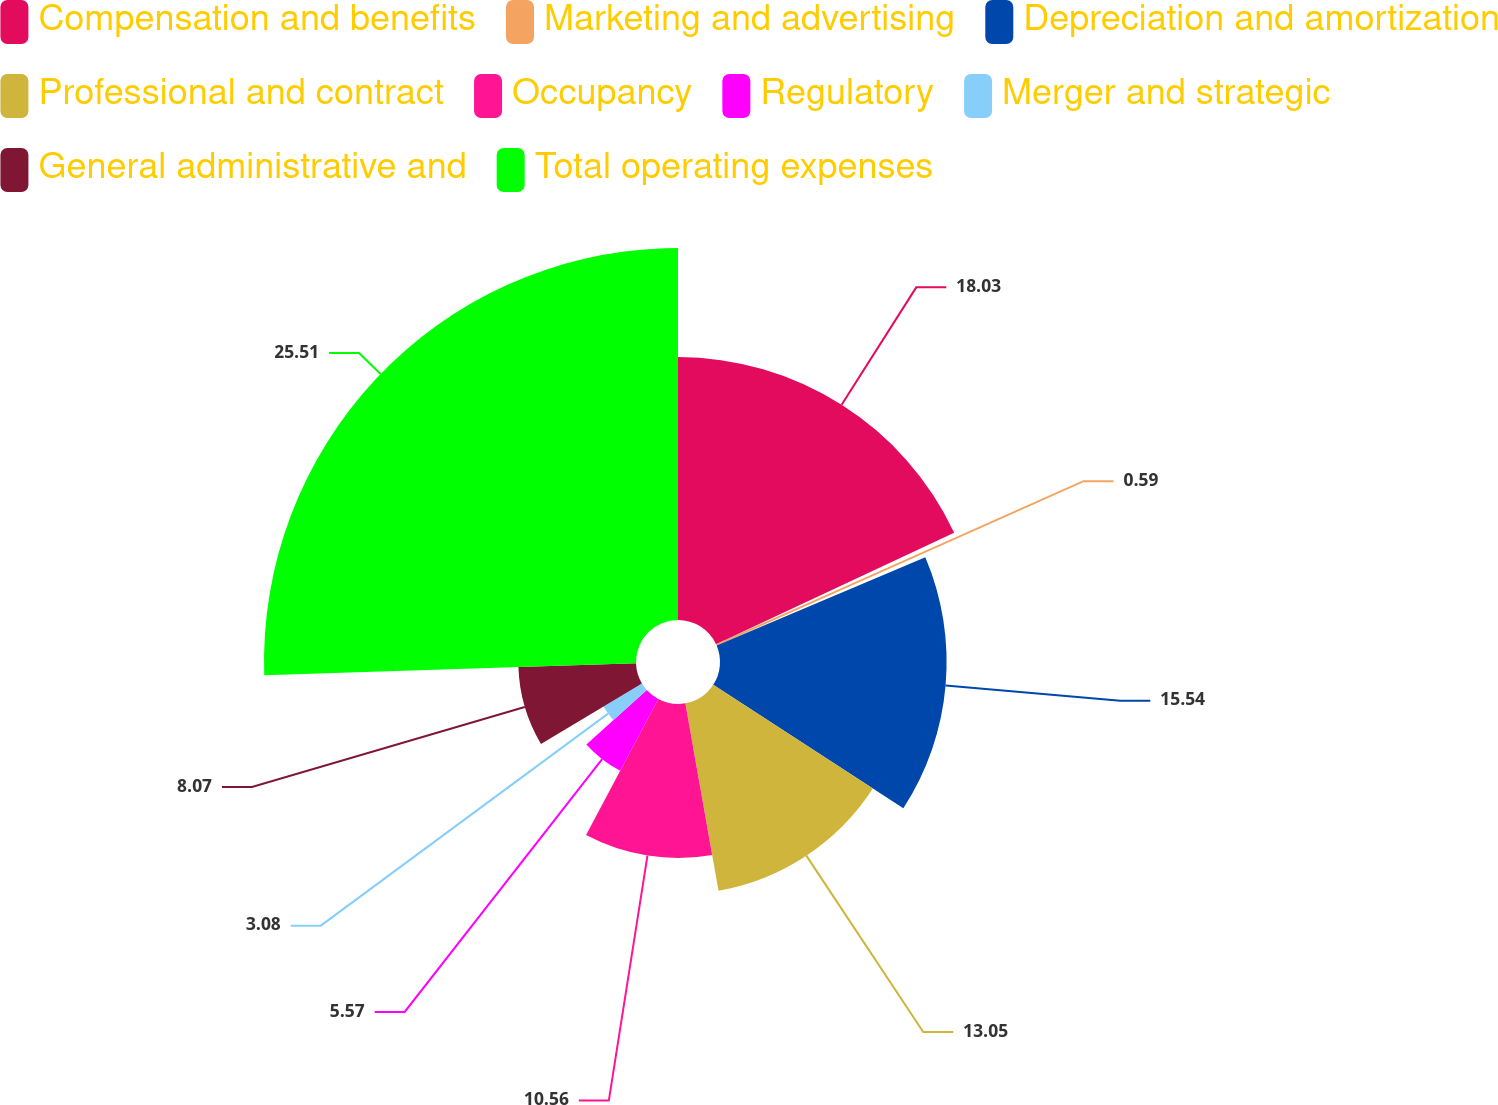<chart> <loc_0><loc_0><loc_500><loc_500><pie_chart><fcel>Compensation and benefits<fcel>Marketing and advertising<fcel>Depreciation and amortization<fcel>Professional and contract<fcel>Occupancy<fcel>Regulatory<fcel>Merger and strategic<fcel>General administrative and<fcel>Total operating expenses<nl><fcel>18.03%<fcel>0.59%<fcel>15.54%<fcel>13.05%<fcel>10.56%<fcel>5.57%<fcel>3.08%<fcel>8.07%<fcel>25.51%<nl></chart> 